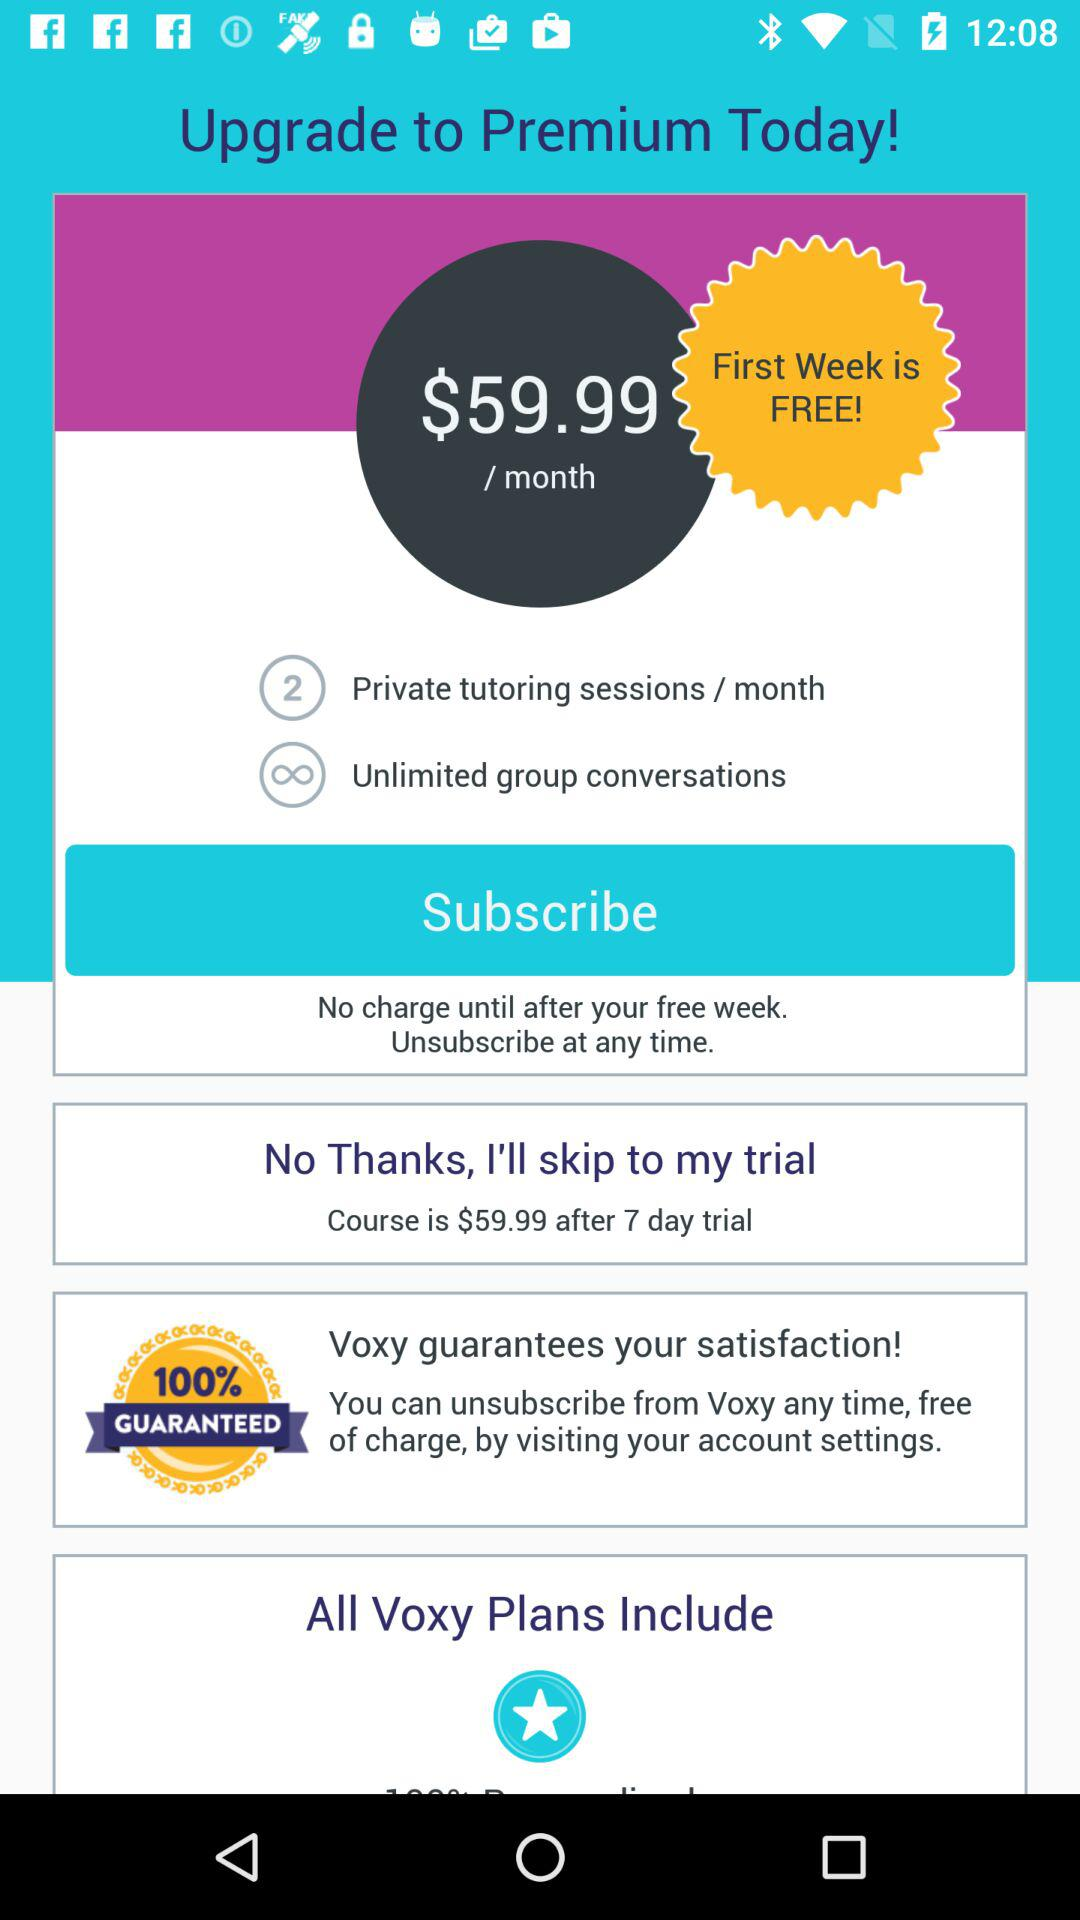How many private tutoring sessions per month? There are 2 private tutoring sessions per month. 